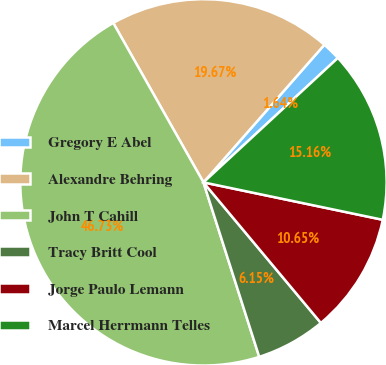Convert chart to OTSL. <chart><loc_0><loc_0><loc_500><loc_500><pie_chart><fcel>Gregory E Abel<fcel>Alexandre Behring<fcel>John T Cahill<fcel>Tracy Britt Cool<fcel>Jorge Paulo Lemann<fcel>Marcel Herrmann Telles<nl><fcel>1.64%<fcel>19.67%<fcel>46.73%<fcel>6.15%<fcel>10.65%<fcel>15.16%<nl></chart> 